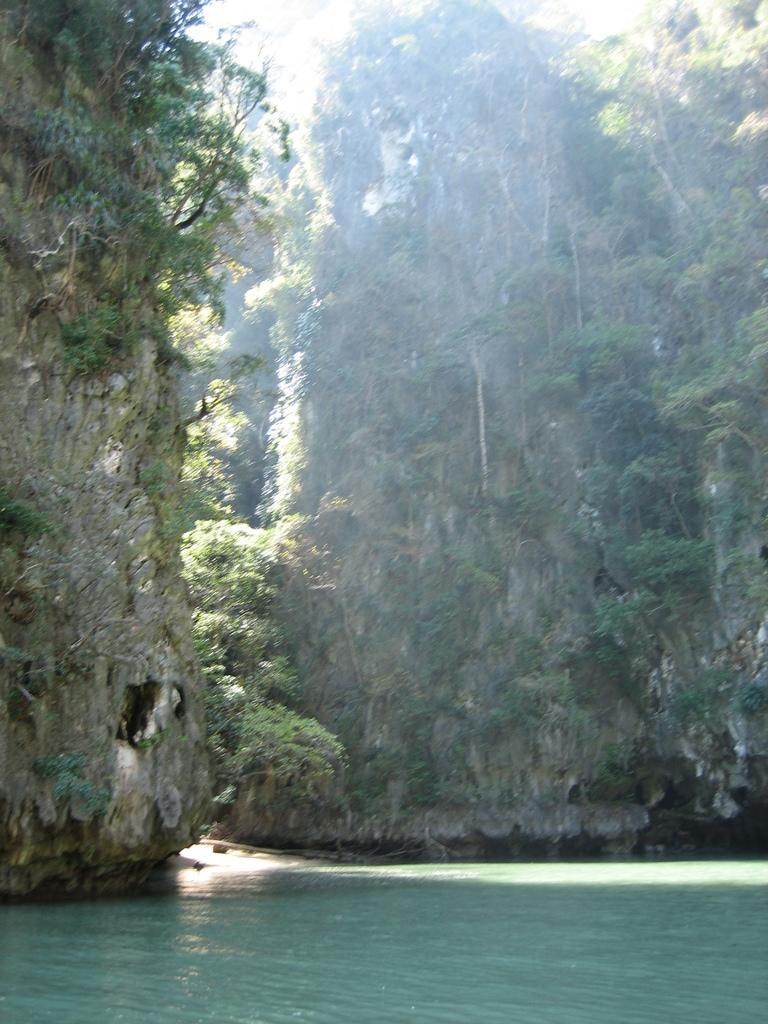What is the primary feature at the bottom of the image? There is a water surface at the bottom of the image. What can be seen on the mountain in the image? There appear to be trees on a mountain in the image. Where is the volleyball court located in the image? There is no volleyball court present in the image. What type of juice can be seen being consumed by the trees on the mountain? There is no juice present in the image; it features a water surface and trees on a mountain. 